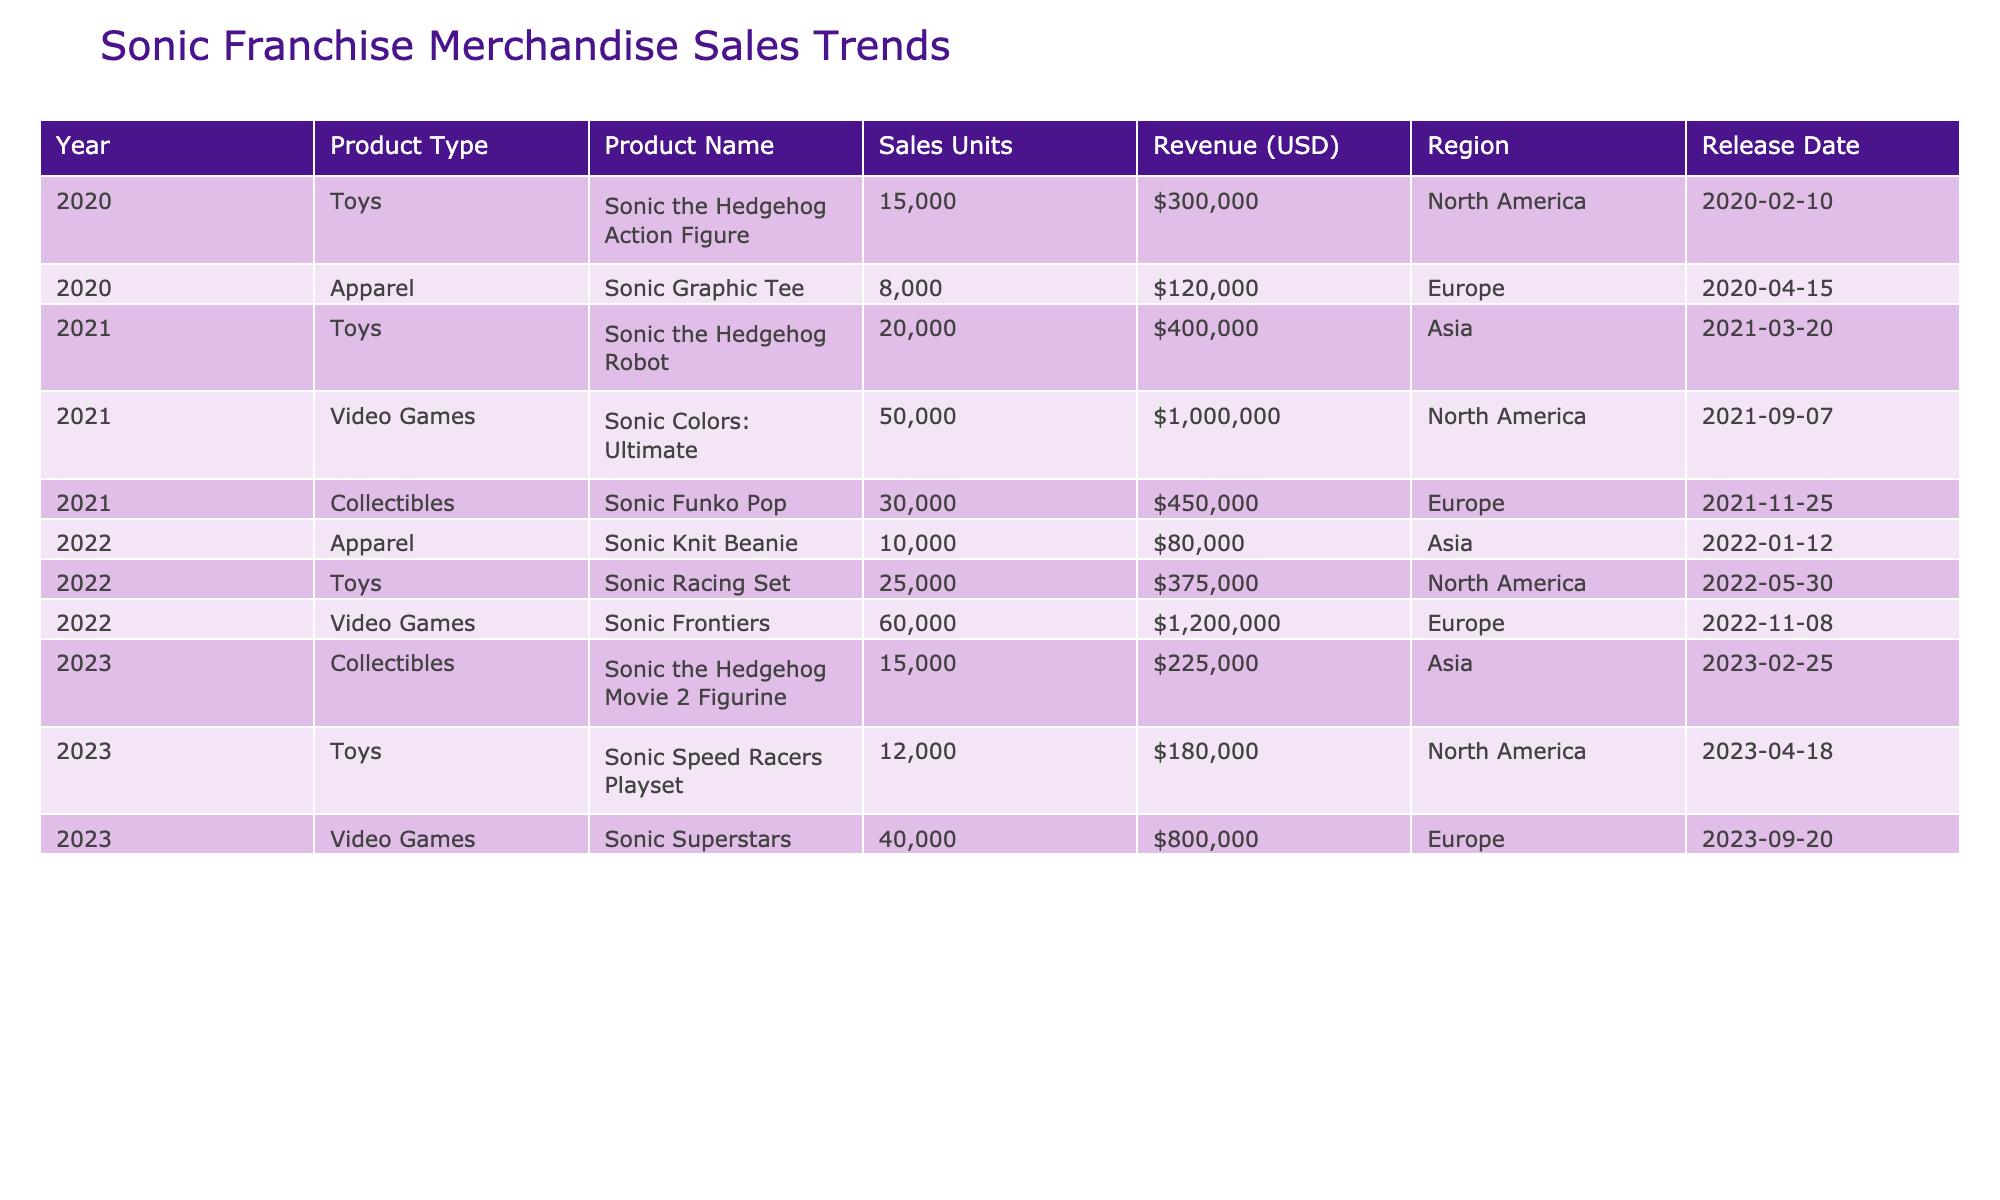What was the revenue from Sonic Colors: Ultimate in North America? The revenue for Sonic Colors: Ultimate in North America is listed in the table under the corresponding row, which is $1,000,000.
Answer: $1,000,000 Which product type had the highest sales units in 2022? In 2022, the sales units for each product type are found in the respective rows. The Sonic Racing Set under Toys had 25,000 sales units, which is the highest for that year.
Answer: Toys What is the average revenue of all Sonic video games listed? The revenues for the video games are $1,000,000 (Sonic Colors: Ultimate), $1,200,000 (Sonic Frontiers), and $800,000 (Sonic Superstars). Summing these gives $3,000,000, and dividing by 3 (the number of video games) results in an average of $1,000,000.
Answer: $1,000,000 Did the sales units for Sonic the Hedgehog Action Figure exceed those for Sonic the Hedgehog Robot? The sales units for Sonic the Hedgehog Action Figure are 15,000, while Sonic the Hedgehog Robot had 20,000 sales units. Since 15,000 is less than 20,000, the statement is false.
Answer: False What was the total revenue for toys sold in North America from 2020 to 2022? The total revenue from toys sold in North America is summed up as follows: $300,000 (Sonic the Hedgehog Action Figure in 2020) + $375,000 (Sonic Racing Set in 2022) + $180,000 (Sonic Speed Racers Playset in 2023) = $855,000.
Answer: $855,000 Which region generated the most revenue from Sonic franchise products in 2021? The table shows that the total revenues in 2021 are $1,000,000 (North America from Sonic Colors: Ultimate) and $450,000 (Europe from Sonic Funko Pop). Therefore, North America generated more revenue.
Answer: North America How many collectible products were released in total from 2020 to 2023? The table provides two collectible products: Sonic Funko Pop (2021) and Sonic the Hedgehog Movie 2 Figurine (2023). Counting these gives a total of 2 collectible products released.
Answer: 2 Was the revenue for Sonic Frontiers lower than the total revenue from all toys sold in 2021? The revenue for Sonic Frontiers is $1,200,000. The total revenue from toys sold in 2021 is $400,000 (Sonic the Hedgehog Robot). Since $1,200,000 is greater than $400,000, the statement is false.
Answer: False What was the percentage increase in sales units for toys from 2020 to 2022? The sales units for toys in 2020 were 15,000, and in 2022, they were 25,000. The increase is 25,000 - 15,000 = 10,000 units. The percentage increase is (10,000 / 15,000) * 100 = 66.67%.
Answer: 66.67% Which product had the latest release date? Comparing all release dates listed in the table, Sonic Superstars was released on September 20, 2023, which is the latest date among the products.
Answer: Sonic Superstars 